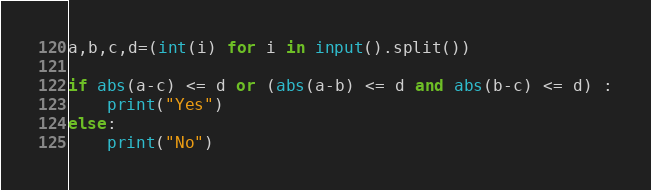<code> <loc_0><loc_0><loc_500><loc_500><_Python_>a,b,c,d=(int(i) for i in input().split())

if abs(a-c) <= d or (abs(a-b) <= d and abs(b-c) <= d) :
    print("Yes")
else:
    print("No")</code> 